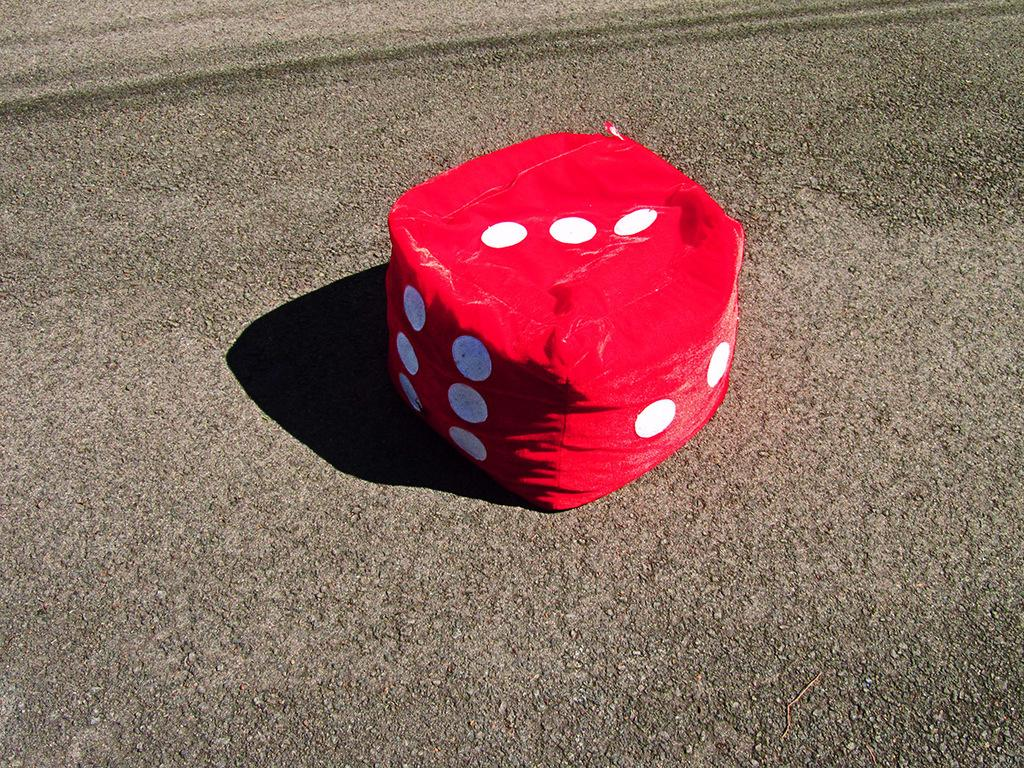Where was the image taken? The image is taken outdoors. What can be seen at the bottom of the image? There is a road at the bottom of the image. What is the main object in the middle of the image? There is a cloth dice with dots in the middle of the image. What magical experience does the cloth dice provide in the image? There is no indication of magic or any magical experience in the image; it simply features a cloth dice with dots. 